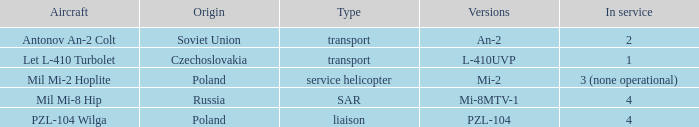Describe the service for variants l-410uvp 1.0. 